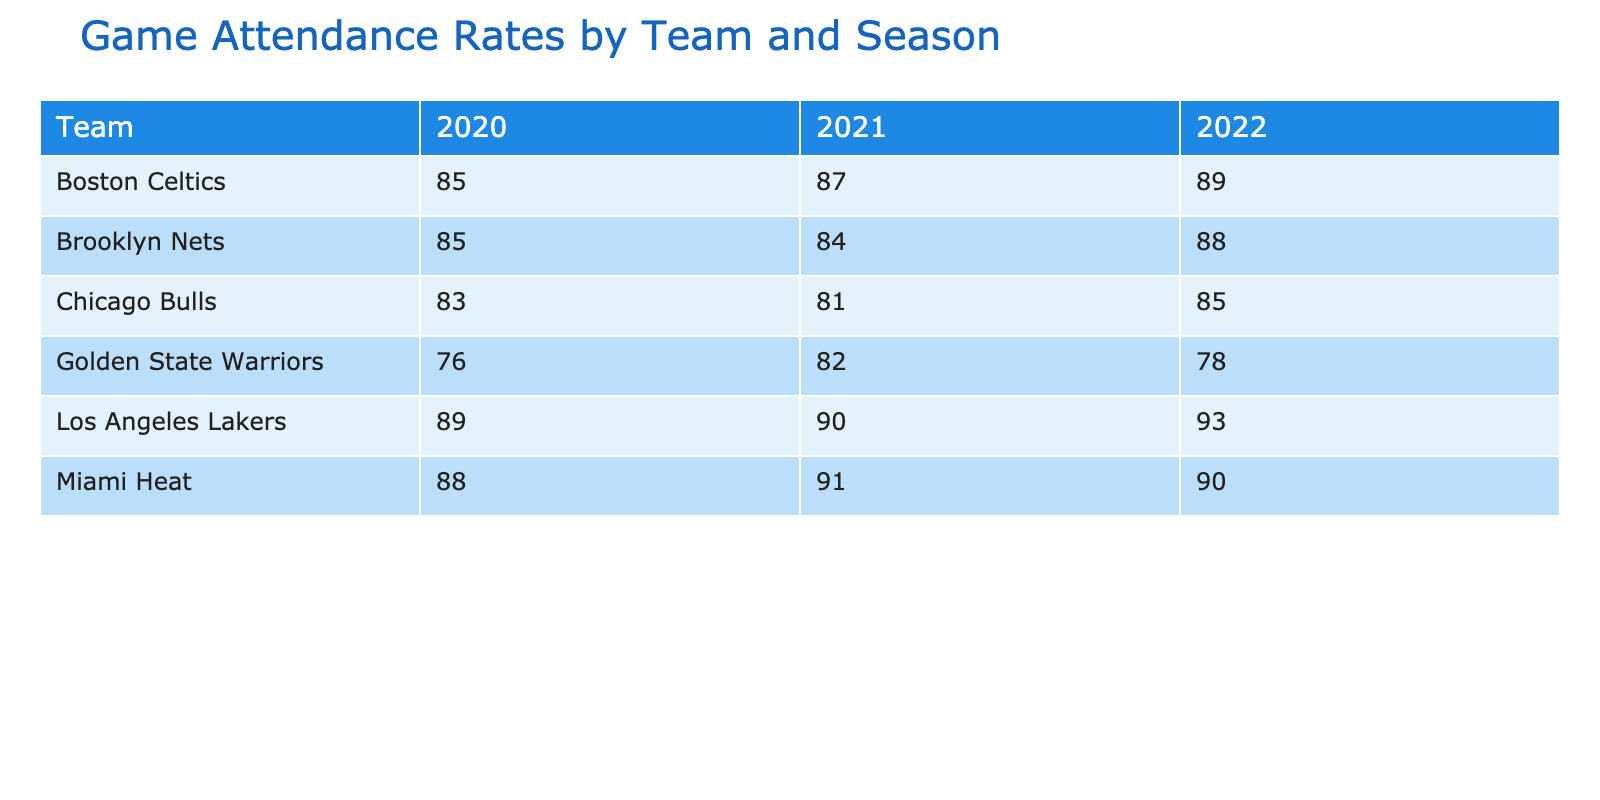What was the attendance rate for the Miami Heat in 2021? The table indicates that the attendance rate for the Miami Heat in the 2021 season is shown in the corresponding row and column. It is listed under the Miami Heat for the season 2021.
Answer: 91 Which team had the highest attendance rate in 2022? By examining the row for each team in the season 2022, I can see the attendance rates: Los Angeles Lakers (93), Boston Celtics (89), Chicago Bulls (85), Miami Heat (90), Golden State Warriors (78), and Brooklyn Nets (88). The highest value is 93 for the Los Angeles Lakers.
Answer: Los Angeles Lakers Is the attendance rate for the Chicago Bulls higher in 2021 compared to 2020? I need to compare the attendance rate for the Chicago Bulls for the years 2021 and 2020. Looking at the table, the attendance rate for 2021 is 81 and for 2020 is 83. Since 81 is less than 83, the statement is false.
Answer: No What is the average attendance rate for the Boston Celtics over the three seasons? To find the average, I need to sum the attendance rates for the Boston Celtics in each season and divide by the number of seasons. The rates are 85 (2020), 87 (2021), and 89 (2022). The total sum is 85 + 87 + 89 = 261. Dividing by 3 gives 261 / 3 = 87.
Answer: 87 Was there any season where the Golden State Warriors had an attendance rate higher than 80? I will check each season's attendance rate for the Golden State Warriors. In 2020, the rate is 76, in 2021 it is 82, and in 2022 it is 78. Only in 2021 does it exceed 80.
Answer: Yes Which teams had attendance rates of 85 or lower in 2021? I will review the attendance rates for 2021 for each team. The attendance rates indicate that the Chicago Bulls (81), Golden State Warriors (82), and Brooklyn Nets (84) had rates of 85 or lower.
Answer: Chicago Bulls, Golden State Warriors, Brooklyn Nets What is the difference in attendance rate between the highest and lowest for the Los Angeles Lakers from 2020 to 2022? For the Los Angeles Lakers, the attendance rates are 89 (2020), 90 (2021), and 93 (2022). The highest is 93 and the lowest is 89. The difference is 93 - 89 = 4.
Answer: 4 Did the Brooklyn Nets have an increasing trend in attendance rates from 2020 to 2022? I will check the attendance rates for the Brooklyn Nets in each season: 85 (2020), 84 (2021), and 88 (2022). The rates show a drop from 2020 to 2021 and then an increase from 2021 to 2022. Hence, the trend is not consistently increasing.
Answer: No 